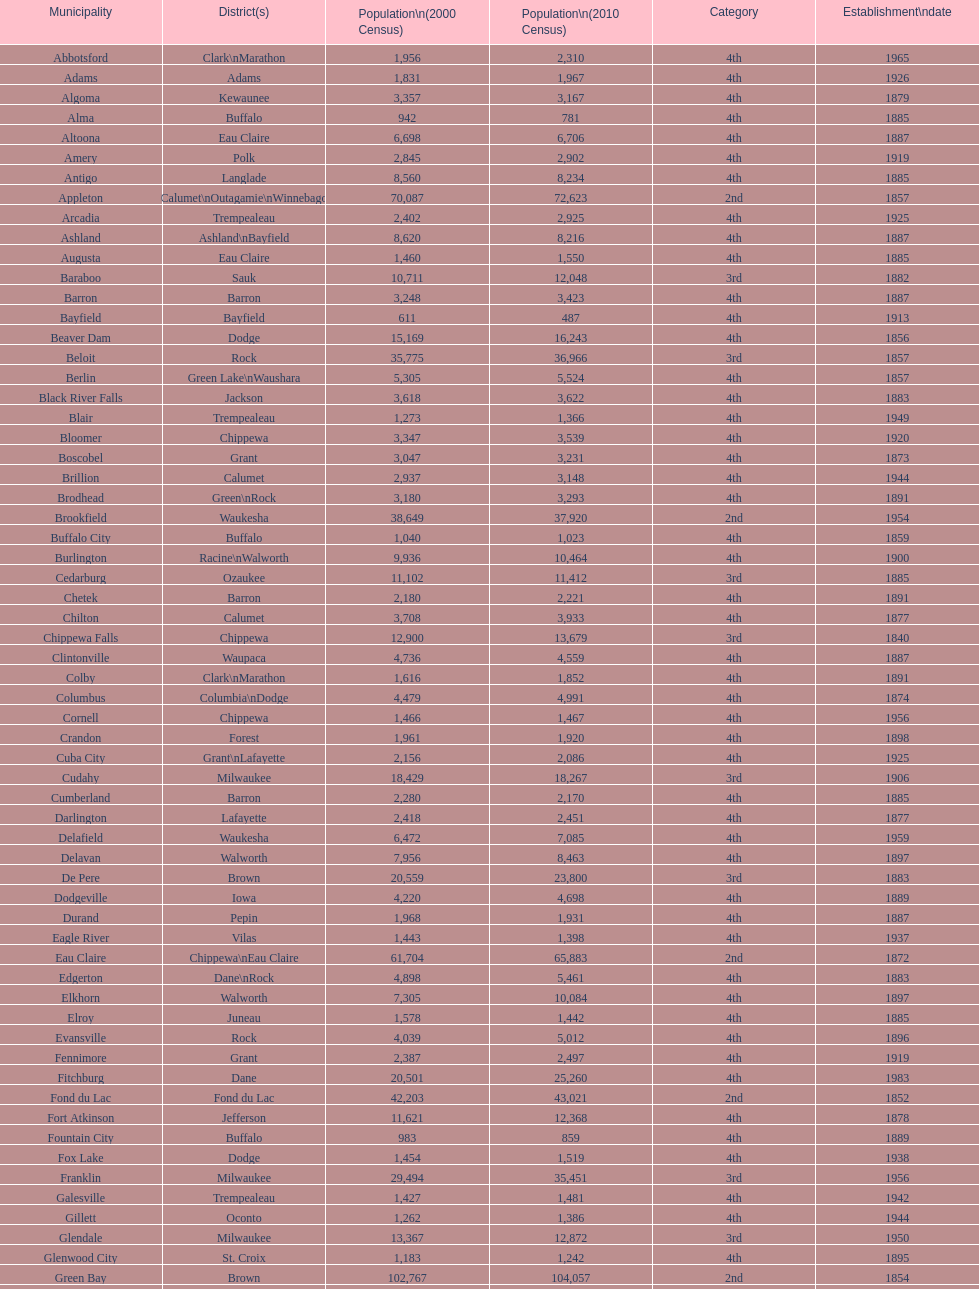What was the first city to be incorporated into wisconsin? Chippewa Falls. 